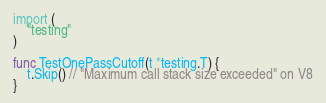<code> <loc_0><loc_0><loc_500><loc_500><_Go_>import (
	"testing"
)

func TestOnePassCutoff(t *testing.T) {
	t.Skip() // "Maximum call stack size exceeded" on V8
}
</code> 